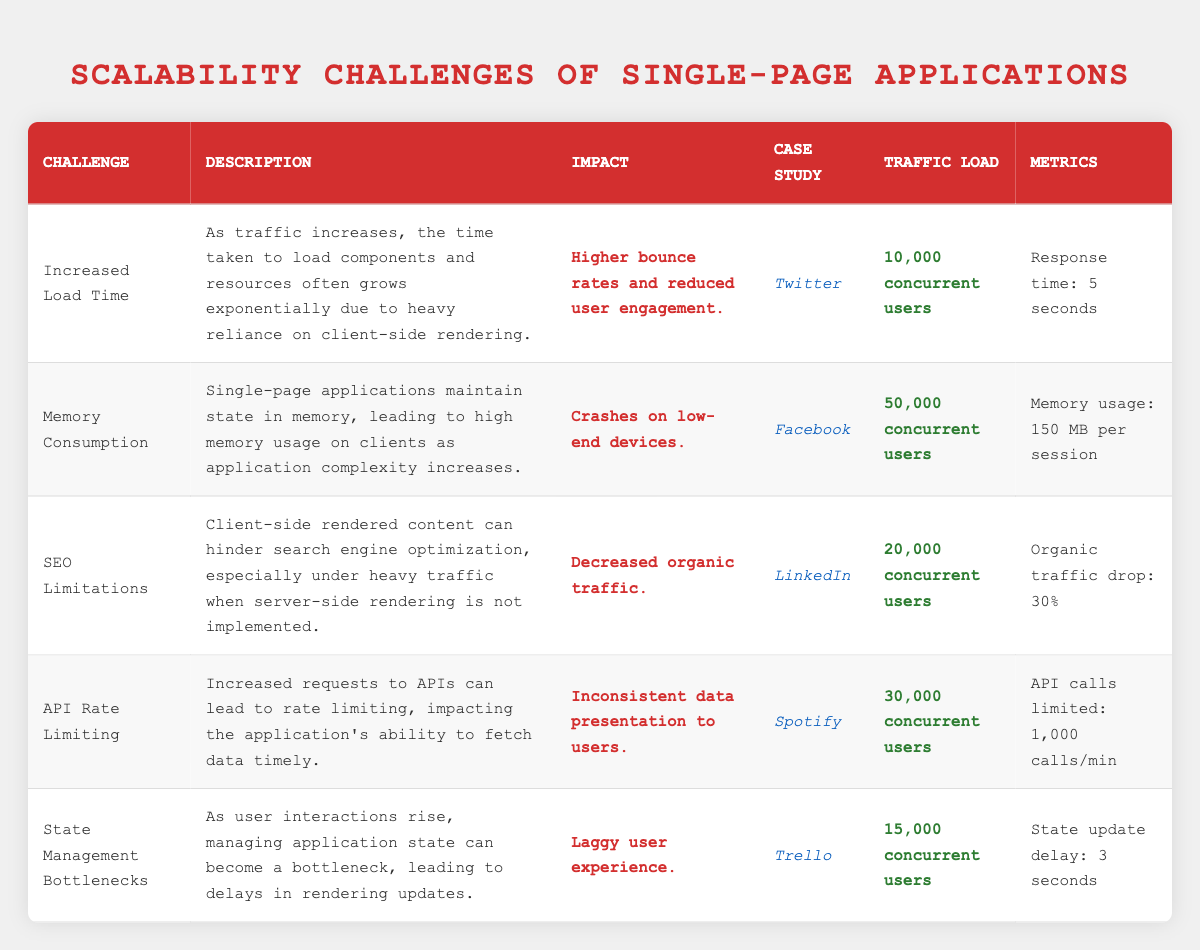What scalability challenge does Twitter face under 10,000 concurrent users? According to the table, Twitter faces the challenge of "Increased Load Time," where the time taken to load components grows significantly with increased traffic.
Answer: Increased Load Time What is the impact of memory consumption challenge for Facebook? The table specifies that the impact of high memory consumption on Facebook is "Crashes on low-end devices."
Answer: Crashes on low-end devices Does Spotify experience API rate limiting with 30,000 concurrent users? Yes, the table indicates that Spotify faces "API Rate Limiting" with "1,000 calls/min" at this traffic load.
Answer: Yes What is the organic traffic drop percentage for LinkedIn under heavy traffic? The table states that LinkedIn experiences a "30%" drop in organic traffic when client-side rendering is heavily used under 20,000 concurrent users.
Answer: 30% Which case study indicates a state management delay of 3 seconds? Referring to the table, Trello is identified as experiencing a "State Management Bottleneck" with a "3 seconds" delay under a traffic load of 15,000 concurrent users.
Answer: Trello What is the combined response time and memory usage for the challenges related to increased load time and memory consumption? The table shows a response time of 5 seconds for Twitter and memory usage of 150 MB per session for Facebook. Since these metrics are not directly comparable, the question implies that they are two separate areas of concern rather than a mathematical combination.
Answer: Not applicable Does any of the case studies indicate a higher concurrency that leads to higher bounce rates? Yes, Twitter shows increased load time impacting user engagement with 10,000 concurrent users, which implies a direct correlation to higher bounce rates when traffic increases.
Answer: Yes What is the relationship between API calls and data presentation for Spotify? The table indicates that increased requests lead to "Inconsistent data presentation to users." At 30,000 concurrent users, API call limits affect the fetching of data, demonstrating a direct challenge in scalability.
Answer: Inconsistent data presentation What is the average memory usage shown across the challenges for the case studies? From the table, the two relevant memory metrics are 150 MB (Facebook) and none directly stated for others, so considering only Facebook, the average based on available data would be 150 MB. However, as there are not multiple data points, a definitive average cannot be calculated accurately.
Answer: 150 MB 